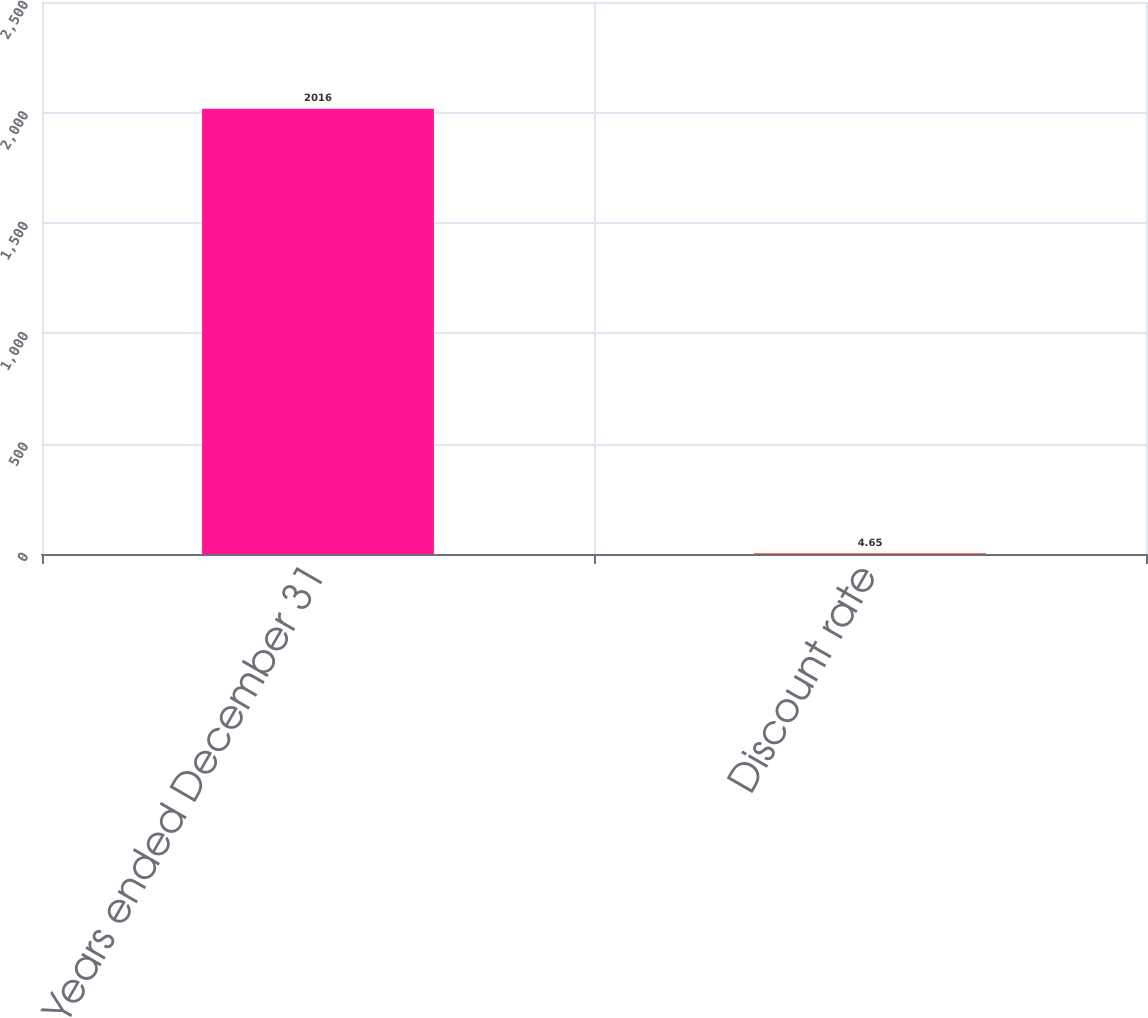Convert chart. <chart><loc_0><loc_0><loc_500><loc_500><bar_chart><fcel>Years ended December 31<fcel>Discount rate<nl><fcel>2016<fcel>4.65<nl></chart> 